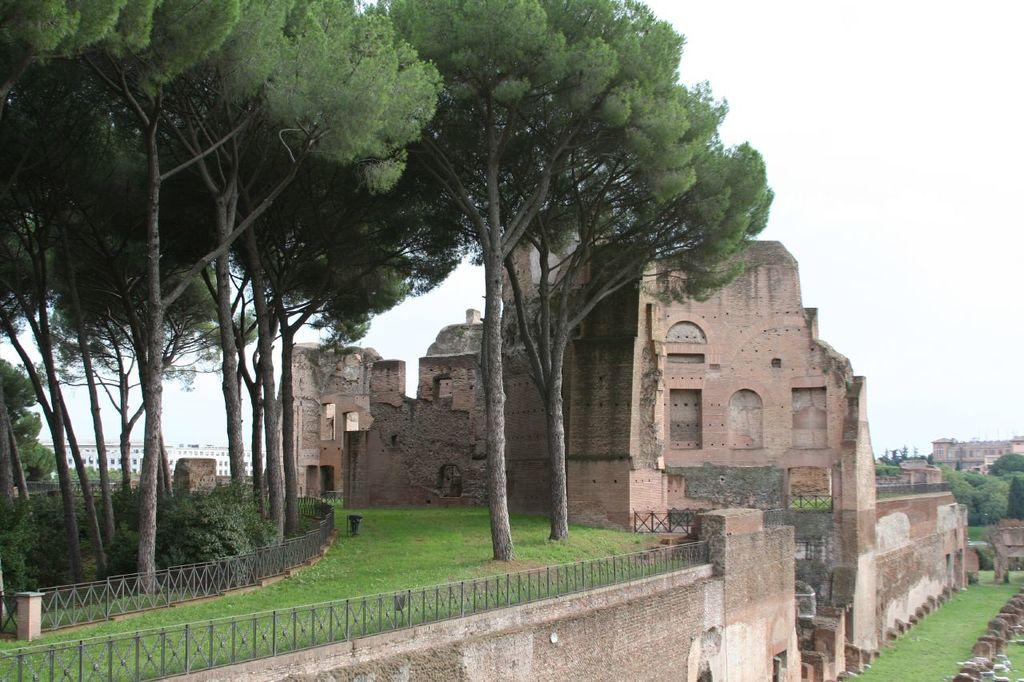What type of vegetation can be seen in the image? There are trees and plants in the image. What other natural elements are present in the image? There is grass in the image. What architectural feature can be seen in the image? There is a castle in the image. What is the condition of the sky in the image? The sky is cloudy in the image. What type of fuel is being used by the castle in the image? There is no information about the castle's fuel source in the image. How does the skirt of the tree in the image move in the wind? There are no skirts present in the image, as trees do not have clothing. 